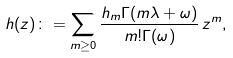Convert formula to latex. <formula><loc_0><loc_0><loc_500><loc_500>h ( z ) \colon = \sum _ { m \geq 0 } \frac { h _ { m } \Gamma ( m \lambda + \omega ) } { m ! \Gamma ( \omega ) } \, z ^ { m } ,</formula> 